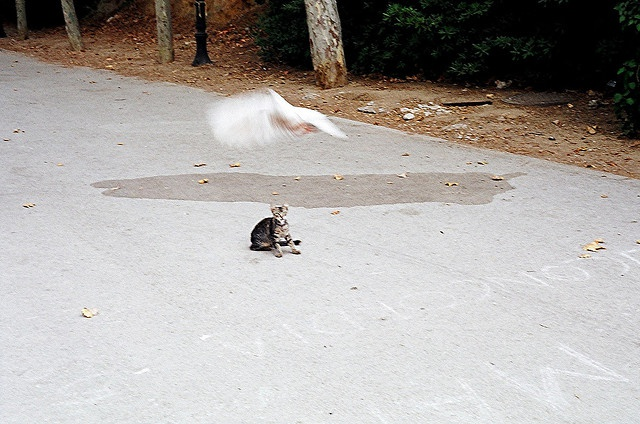Describe the objects in this image and their specific colors. I can see bird in black, lightgray, and darkgray tones and cat in black, gray, lightgray, and darkgray tones in this image. 